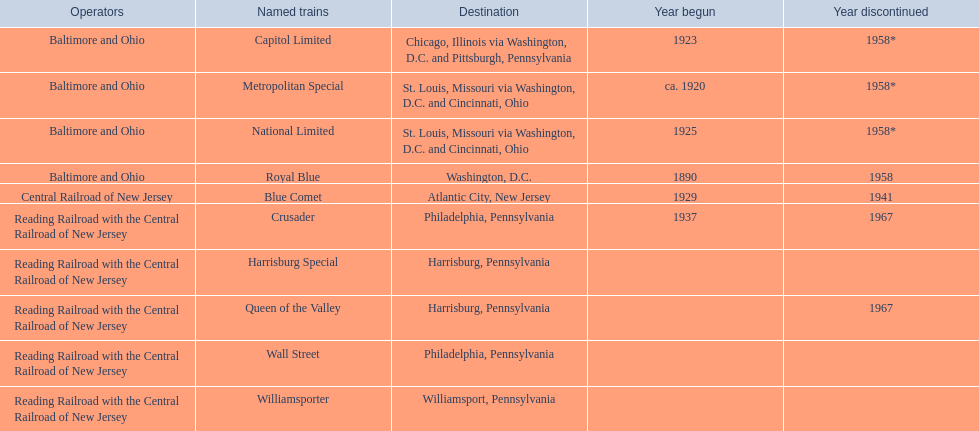What were all of the destinations? Chicago, Illinois via Washington, D.C. and Pittsburgh, Pennsylvania, St. Louis, Missouri via Washington, D.C. and Cincinnati, Ohio, St. Louis, Missouri via Washington, D.C. and Cincinnati, Ohio, Washington, D.C., Atlantic City, New Jersey, Philadelphia, Pennsylvania, Harrisburg, Pennsylvania, Harrisburg, Pennsylvania, Philadelphia, Pennsylvania, Williamsport, Pennsylvania. And what were the names of the trains? Capitol Limited, Metropolitan Special, National Limited, Royal Blue, Blue Comet, Crusader, Harrisburg Special, Queen of the Valley, Wall Street, Williamsporter. Of those, and along with wall street, which train ran to philadelphia, pennsylvania? Crusader. 